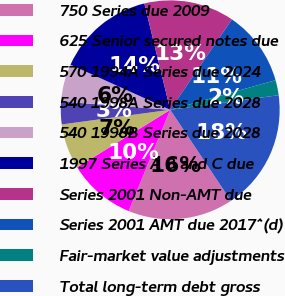Convert chart. <chart><loc_0><loc_0><loc_500><loc_500><pie_chart><fcel>750 Series due 2009<fcel>625 Senior secured notes due<fcel>570 1994A Series due 2024<fcel>540 1998A Series due 2028<fcel>540 1998B Series due 2028<fcel>1997 Series A B and C due<fcel>Series 2001 Non-AMT due<fcel>Series 2001 AMT due 2017^(d)<fcel>Fair-market value adjustments<fcel>Total long-term debt gross<nl><fcel>15.55%<fcel>10.0%<fcel>6.67%<fcel>3.34%<fcel>5.56%<fcel>14.44%<fcel>13.33%<fcel>11.11%<fcel>2.23%<fcel>17.77%<nl></chart> 